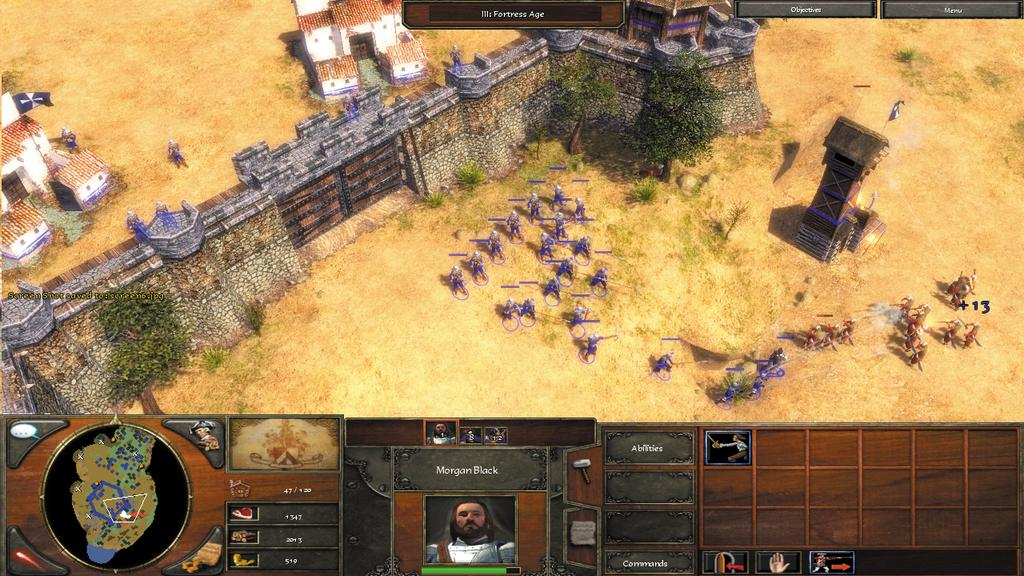What type of image is depicted in the screenshot? The image appears to be a screenshot of a video game. How many ladybugs can be seen in the video game screenshot? A: There are no ladybugs visible in the image, as it is a screenshot of a video game and not a photograph of a real-life scene. 